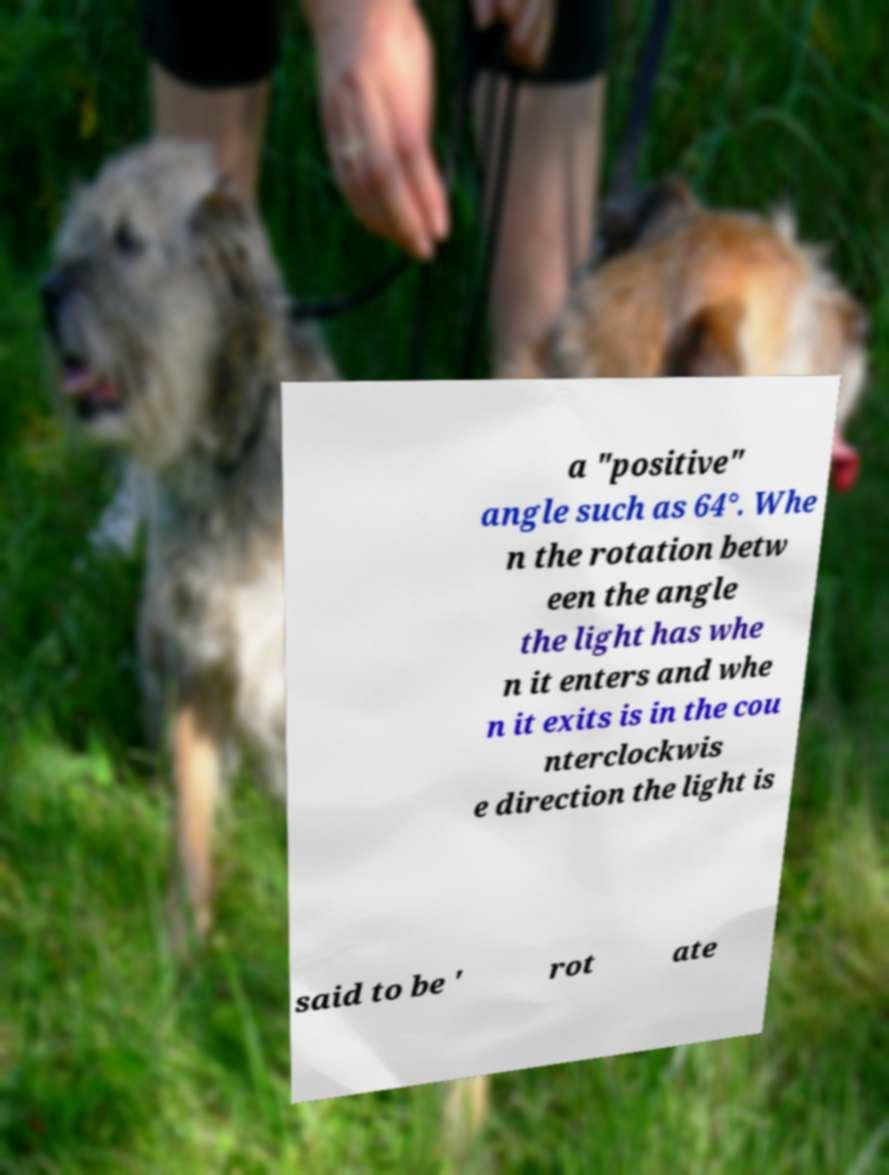I need the written content from this picture converted into text. Can you do that? a "positive" angle such as 64°. Whe n the rotation betw een the angle the light has whe n it enters and whe n it exits is in the cou nterclockwis e direction the light is said to be ' rot ate 